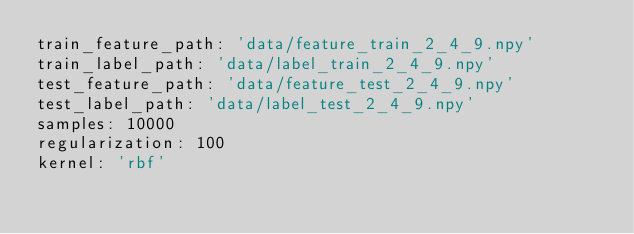<code> <loc_0><loc_0><loc_500><loc_500><_YAML_>train_feature_path: 'data/feature_train_2_4_9.npy'
train_label_path: 'data/label_train_2_4_9.npy'
test_feature_path: 'data/feature_test_2_4_9.npy'
test_label_path: 'data/label_test_2_4_9.npy'
samples: 10000
regularization: 100
kernel: 'rbf'</code> 